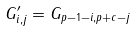Convert formula to latex. <formula><loc_0><loc_0><loc_500><loc_500>G ^ { \prime } _ { i , j } = G _ { p - 1 - i , p + c - j }</formula> 